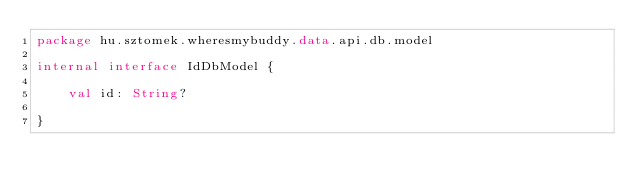<code> <loc_0><loc_0><loc_500><loc_500><_Kotlin_>package hu.sztomek.wheresmybuddy.data.api.db.model

internal interface IdDbModel {

    val id: String?

}</code> 